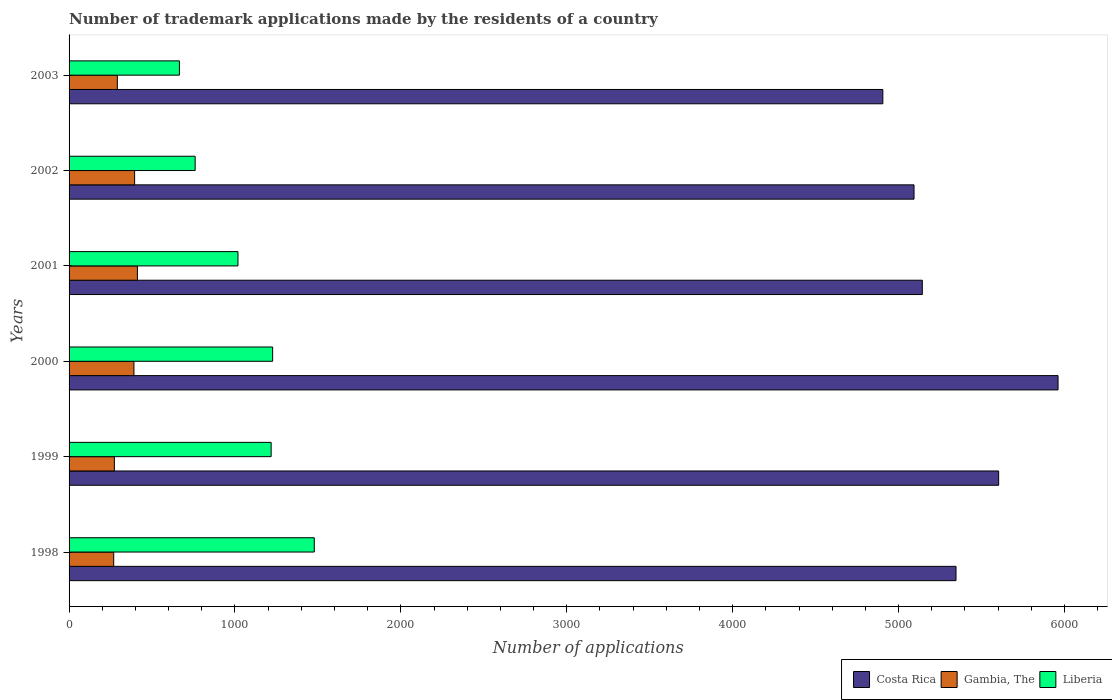How many groups of bars are there?
Give a very brief answer. 6. Are the number of bars per tick equal to the number of legend labels?
Your answer should be very brief. Yes. Are the number of bars on each tick of the Y-axis equal?
Provide a succinct answer. Yes. How many bars are there on the 4th tick from the bottom?
Provide a short and direct response. 3. In how many cases, is the number of bars for a given year not equal to the number of legend labels?
Your answer should be compact. 0. What is the number of trademark applications made by the residents in Costa Rica in 2003?
Make the answer very short. 4905. Across all years, what is the maximum number of trademark applications made by the residents in Gambia, The?
Offer a very short reply. 412. Across all years, what is the minimum number of trademark applications made by the residents in Gambia, The?
Provide a succinct answer. 269. In which year was the number of trademark applications made by the residents in Gambia, The maximum?
Make the answer very short. 2001. In which year was the number of trademark applications made by the residents in Costa Rica minimum?
Your answer should be very brief. 2003. What is the total number of trademark applications made by the residents in Liberia in the graph?
Give a very brief answer. 6366. What is the difference between the number of trademark applications made by the residents in Gambia, The in 1998 and that in 2000?
Offer a very short reply. -122. What is the difference between the number of trademark applications made by the residents in Costa Rica in 2003 and the number of trademark applications made by the residents in Gambia, The in 2002?
Offer a very short reply. 4510. What is the average number of trademark applications made by the residents in Costa Rica per year?
Your answer should be compact. 5341.83. In the year 2001, what is the difference between the number of trademark applications made by the residents in Gambia, The and number of trademark applications made by the residents in Costa Rica?
Give a very brief answer. -4731. What is the ratio of the number of trademark applications made by the residents in Gambia, The in 1998 to that in 2001?
Offer a very short reply. 0.65. Is the difference between the number of trademark applications made by the residents in Gambia, The in 1999 and 2001 greater than the difference between the number of trademark applications made by the residents in Costa Rica in 1999 and 2001?
Your answer should be compact. No. What is the difference between the highest and the lowest number of trademark applications made by the residents in Costa Rica?
Make the answer very short. 1056. What is the difference between two consecutive major ticks on the X-axis?
Make the answer very short. 1000. Are the values on the major ticks of X-axis written in scientific E-notation?
Give a very brief answer. No. Does the graph contain any zero values?
Give a very brief answer. No. Does the graph contain grids?
Your answer should be very brief. No. Where does the legend appear in the graph?
Your answer should be compact. Bottom right. How many legend labels are there?
Your answer should be compact. 3. How are the legend labels stacked?
Your response must be concise. Horizontal. What is the title of the graph?
Offer a very short reply. Number of trademark applications made by the residents of a country. Does "Cote d'Ivoire" appear as one of the legend labels in the graph?
Offer a terse response. No. What is the label or title of the X-axis?
Offer a very short reply. Number of applications. What is the label or title of the Y-axis?
Your answer should be compact. Years. What is the Number of applications of Costa Rica in 1998?
Your answer should be very brief. 5346. What is the Number of applications of Gambia, The in 1998?
Your response must be concise. 269. What is the Number of applications in Liberia in 1998?
Your response must be concise. 1478. What is the Number of applications in Costa Rica in 1999?
Provide a succinct answer. 5603. What is the Number of applications in Gambia, The in 1999?
Your answer should be very brief. 273. What is the Number of applications in Liberia in 1999?
Make the answer very short. 1218. What is the Number of applications of Costa Rica in 2000?
Provide a short and direct response. 5961. What is the Number of applications of Gambia, The in 2000?
Your answer should be very brief. 391. What is the Number of applications in Liberia in 2000?
Offer a terse response. 1227. What is the Number of applications in Costa Rica in 2001?
Provide a short and direct response. 5143. What is the Number of applications of Gambia, The in 2001?
Ensure brevity in your answer.  412. What is the Number of applications of Liberia in 2001?
Offer a very short reply. 1018. What is the Number of applications of Costa Rica in 2002?
Your answer should be compact. 5093. What is the Number of applications in Gambia, The in 2002?
Keep it short and to the point. 395. What is the Number of applications of Liberia in 2002?
Provide a short and direct response. 760. What is the Number of applications in Costa Rica in 2003?
Make the answer very short. 4905. What is the Number of applications of Gambia, The in 2003?
Ensure brevity in your answer.  291. What is the Number of applications in Liberia in 2003?
Provide a succinct answer. 665. Across all years, what is the maximum Number of applications of Costa Rica?
Your answer should be very brief. 5961. Across all years, what is the maximum Number of applications in Gambia, The?
Ensure brevity in your answer.  412. Across all years, what is the maximum Number of applications of Liberia?
Your answer should be very brief. 1478. Across all years, what is the minimum Number of applications of Costa Rica?
Provide a short and direct response. 4905. Across all years, what is the minimum Number of applications of Gambia, The?
Your answer should be compact. 269. Across all years, what is the minimum Number of applications in Liberia?
Provide a succinct answer. 665. What is the total Number of applications of Costa Rica in the graph?
Make the answer very short. 3.21e+04. What is the total Number of applications in Gambia, The in the graph?
Your answer should be very brief. 2031. What is the total Number of applications of Liberia in the graph?
Ensure brevity in your answer.  6366. What is the difference between the Number of applications of Costa Rica in 1998 and that in 1999?
Your answer should be compact. -257. What is the difference between the Number of applications in Gambia, The in 1998 and that in 1999?
Offer a terse response. -4. What is the difference between the Number of applications of Liberia in 1998 and that in 1999?
Keep it short and to the point. 260. What is the difference between the Number of applications of Costa Rica in 1998 and that in 2000?
Your answer should be very brief. -615. What is the difference between the Number of applications in Gambia, The in 1998 and that in 2000?
Provide a succinct answer. -122. What is the difference between the Number of applications in Liberia in 1998 and that in 2000?
Provide a short and direct response. 251. What is the difference between the Number of applications of Costa Rica in 1998 and that in 2001?
Make the answer very short. 203. What is the difference between the Number of applications in Gambia, The in 1998 and that in 2001?
Ensure brevity in your answer.  -143. What is the difference between the Number of applications in Liberia in 1998 and that in 2001?
Your answer should be very brief. 460. What is the difference between the Number of applications of Costa Rica in 1998 and that in 2002?
Provide a succinct answer. 253. What is the difference between the Number of applications of Gambia, The in 1998 and that in 2002?
Your response must be concise. -126. What is the difference between the Number of applications of Liberia in 1998 and that in 2002?
Offer a very short reply. 718. What is the difference between the Number of applications in Costa Rica in 1998 and that in 2003?
Provide a short and direct response. 441. What is the difference between the Number of applications of Liberia in 1998 and that in 2003?
Provide a short and direct response. 813. What is the difference between the Number of applications in Costa Rica in 1999 and that in 2000?
Your response must be concise. -358. What is the difference between the Number of applications in Gambia, The in 1999 and that in 2000?
Ensure brevity in your answer.  -118. What is the difference between the Number of applications of Liberia in 1999 and that in 2000?
Provide a succinct answer. -9. What is the difference between the Number of applications in Costa Rica in 1999 and that in 2001?
Give a very brief answer. 460. What is the difference between the Number of applications in Gambia, The in 1999 and that in 2001?
Ensure brevity in your answer.  -139. What is the difference between the Number of applications of Liberia in 1999 and that in 2001?
Ensure brevity in your answer.  200. What is the difference between the Number of applications in Costa Rica in 1999 and that in 2002?
Provide a short and direct response. 510. What is the difference between the Number of applications of Gambia, The in 1999 and that in 2002?
Provide a short and direct response. -122. What is the difference between the Number of applications in Liberia in 1999 and that in 2002?
Make the answer very short. 458. What is the difference between the Number of applications in Costa Rica in 1999 and that in 2003?
Your response must be concise. 698. What is the difference between the Number of applications in Gambia, The in 1999 and that in 2003?
Make the answer very short. -18. What is the difference between the Number of applications in Liberia in 1999 and that in 2003?
Ensure brevity in your answer.  553. What is the difference between the Number of applications of Costa Rica in 2000 and that in 2001?
Keep it short and to the point. 818. What is the difference between the Number of applications of Gambia, The in 2000 and that in 2001?
Your answer should be very brief. -21. What is the difference between the Number of applications in Liberia in 2000 and that in 2001?
Give a very brief answer. 209. What is the difference between the Number of applications of Costa Rica in 2000 and that in 2002?
Ensure brevity in your answer.  868. What is the difference between the Number of applications of Gambia, The in 2000 and that in 2002?
Offer a very short reply. -4. What is the difference between the Number of applications of Liberia in 2000 and that in 2002?
Make the answer very short. 467. What is the difference between the Number of applications of Costa Rica in 2000 and that in 2003?
Provide a short and direct response. 1056. What is the difference between the Number of applications of Liberia in 2000 and that in 2003?
Make the answer very short. 562. What is the difference between the Number of applications of Liberia in 2001 and that in 2002?
Make the answer very short. 258. What is the difference between the Number of applications in Costa Rica in 2001 and that in 2003?
Your answer should be very brief. 238. What is the difference between the Number of applications in Gambia, The in 2001 and that in 2003?
Keep it short and to the point. 121. What is the difference between the Number of applications of Liberia in 2001 and that in 2003?
Offer a terse response. 353. What is the difference between the Number of applications of Costa Rica in 2002 and that in 2003?
Offer a very short reply. 188. What is the difference between the Number of applications in Gambia, The in 2002 and that in 2003?
Give a very brief answer. 104. What is the difference between the Number of applications of Costa Rica in 1998 and the Number of applications of Gambia, The in 1999?
Offer a very short reply. 5073. What is the difference between the Number of applications in Costa Rica in 1998 and the Number of applications in Liberia in 1999?
Ensure brevity in your answer.  4128. What is the difference between the Number of applications in Gambia, The in 1998 and the Number of applications in Liberia in 1999?
Keep it short and to the point. -949. What is the difference between the Number of applications in Costa Rica in 1998 and the Number of applications in Gambia, The in 2000?
Your answer should be compact. 4955. What is the difference between the Number of applications in Costa Rica in 1998 and the Number of applications in Liberia in 2000?
Keep it short and to the point. 4119. What is the difference between the Number of applications of Gambia, The in 1998 and the Number of applications of Liberia in 2000?
Keep it short and to the point. -958. What is the difference between the Number of applications of Costa Rica in 1998 and the Number of applications of Gambia, The in 2001?
Provide a succinct answer. 4934. What is the difference between the Number of applications in Costa Rica in 1998 and the Number of applications in Liberia in 2001?
Provide a short and direct response. 4328. What is the difference between the Number of applications in Gambia, The in 1998 and the Number of applications in Liberia in 2001?
Keep it short and to the point. -749. What is the difference between the Number of applications of Costa Rica in 1998 and the Number of applications of Gambia, The in 2002?
Provide a succinct answer. 4951. What is the difference between the Number of applications in Costa Rica in 1998 and the Number of applications in Liberia in 2002?
Ensure brevity in your answer.  4586. What is the difference between the Number of applications of Gambia, The in 1998 and the Number of applications of Liberia in 2002?
Ensure brevity in your answer.  -491. What is the difference between the Number of applications of Costa Rica in 1998 and the Number of applications of Gambia, The in 2003?
Keep it short and to the point. 5055. What is the difference between the Number of applications of Costa Rica in 1998 and the Number of applications of Liberia in 2003?
Your answer should be compact. 4681. What is the difference between the Number of applications of Gambia, The in 1998 and the Number of applications of Liberia in 2003?
Your answer should be compact. -396. What is the difference between the Number of applications in Costa Rica in 1999 and the Number of applications in Gambia, The in 2000?
Keep it short and to the point. 5212. What is the difference between the Number of applications in Costa Rica in 1999 and the Number of applications in Liberia in 2000?
Your answer should be compact. 4376. What is the difference between the Number of applications of Gambia, The in 1999 and the Number of applications of Liberia in 2000?
Give a very brief answer. -954. What is the difference between the Number of applications in Costa Rica in 1999 and the Number of applications in Gambia, The in 2001?
Your response must be concise. 5191. What is the difference between the Number of applications of Costa Rica in 1999 and the Number of applications of Liberia in 2001?
Provide a short and direct response. 4585. What is the difference between the Number of applications in Gambia, The in 1999 and the Number of applications in Liberia in 2001?
Your answer should be compact. -745. What is the difference between the Number of applications of Costa Rica in 1999 and the Number of applications of Gambia, The in 2002?
Provide a succinct answer. 5208. What is the difference between the Number of applications in Costa Rica in 1999 and the Number of applications in Liberia in 2002?
Keep it short and to the point. 4843. What is the difference between the Number of applications in Gambia, The in 1999 and the Number of applications in Liberia in 2002?
Give a very brief answer. -487. What is the difference between the Number of applications in Costa Rica in 1999 and the Number of applications in Gambia, The in 2003?
Give a very brief answer. 5312. What is the difference between the Number of applications in Costa Rica in 1999 and the Number of applications in Liberia in 2003?
Your response must be concise. 4938. What is the difference between the Number of applications in Gambia, The in 1999 and the Number of applications in Liberia in 2003?
Your answer should be compact. -392. What is the difference between the Number of applications in Costa Rica in 2000 and the Number of applications in Gambia, The in 2001?
Offer a very short reply. 5549. What is the difference between the Number of applications of Costa Rica in 2000 and the Number of applications of Liberia in 2001?
Ensure brevity in your answer.  4943. What is the difference between the Number of applications in Gambia, The in 2000 and the Number of applications in Liberia in 2001?
Give a very brief answer. -627. What is the difference between the Number of applications in Costa Rica in 2000 and the Number of applications in Gambia, The in 2002?
Provide a short and direct response. 5566. What is the difference between the Number of applications of Costa Rica in 2000 and the Number of applications of Liberia in 2002?
Ensure brevity in your answer.  5201. What is the difference between the Number of applications of Gambia, The in 2000 and the Number of applications of Liberia in 2002?
Offer a terse response. -369. What is the difference between the Number of applications of Costa Rica in 2000 and the Number of applications of Gambia, The in 2003?
Provide a short and direct response. 5670. What is the difference between the Number of applications of Costa Rica in 2000 and the Number of applications of Liberia in 2003?
Provide a short and direct response. 5296. What is the difference between the Number of applications in Gambia, The in 2000 and the Number of applications in Liberia in 2003?
Provide a succinct answer. -274. What is the difference between the Number of applications in Costa Rica in 2001 and the Number of applications in Gambia, The in 2002?
Offer a terse response. 4748. What is the difference between the Number of applications of Costa Rica in 2001 and the Number of applications of Liberia in 2002?
Your response must be concise. 4383. What is the difference between the Number of applications in Gambia, The in 2001 and the Number of applications in Liberia in 2002?
Provide a short and direct response. -348. What is the difference between the Number of applications in Costa Rica in 2001 and the Number of applications in Gambia, The in 2003?
Keep it short and to the point. 4852. What is the difference between the Number of applications in Costa Rica in 2001 and the Number of applications in Liberia in 2003?
Your answer should be compact. 4478. What is the difference between the Number of applications of Gambia, The in 2001 and the Number of applications of Liberia in 2003?
Your answer should be compact. -253. What is the difference between the Number of applications of Costa Rica in 2002 and the Number of applications of Gambia, The in 2003?
Your answer should be compact. 4802. What is the difference between the Number of applications of Costa Rica in 2002 and the Number of applications of Liberia in 2003?
Ensure brevity in your answer.  4428. What is the difference between the Number of applications of Gambia, The in 2002 and the Number of applications of Liberia in 2003?
Offer a terse response. -270. What is the average Number of applications of Costa Rica per year?
Ensure brevity in your answer.  5341.83. What is the average Number of applications of Gambia, The per year?
Your answer should be very brief. 338.5. What is the average Number of applications of Liberia per year?
Your answer should be very brief. 1061. In the year 1998, what is the difference between the Number of applications of Costa Rica and Number of applications of Gambia, The?
Provide a short and direct response. 5077. In the year 1998, what is the difference between the Number of applications of Costa Rica and Number of applications of Liberia?
Offer a terse response. 3868. In the year 1998, what is the difference between the Number of applications of Gambia, The and Number of applications of Liberia?
Offer a terse response. -1209. In the year 1999, what is the difference between the Number of applications of Costa Rica and Number of applications of Gambia, The?
Your answer should be very brief. 5330. In the year 1999, what is the difference between the Number of applications of Costa Rica and Number of applications of Liberia?
Make the answer very short. 4385. In the year 1999, what is the difference between the Number of applications of Gambia, The and Number of applications of Liberia?
Your answer should be very brief. -945. In the year 2000, what is the difference between the Number of applications of Costa Rica and Number of applications of Gambia, The?
Offer a very short reply. 5570. In the year 2000, what is the difference between the Number of applications of Costa Rica and Number of applications of Liberia?
Offer a very short reply. 4734. In the year 2000, what is the difference between the Number of applications in Gambia, The and Number of applications in Liberia?
Your response must be concise. -836. In the year 2001, what is the difference between the Number of applications of Costa Rica and Number of applications of Gambia, The?
Give a very brief answer. 4731. In the year 2001, what is the difference between the Number of applications in Costa Rica and Number of applications in Liberia?
Provide a succinct answer. 4125. In the year 2001, what is the difference between the Number of applications of Gambia, The and Number of applications of Liberia?
Your answer should be compact. -606. In the year 2002, what is the difference between the Number of applications of Costa Rica and Number of applications of Gambia, The?
Give a very brief answer. 4698. In the year 2002, what is the difference between the Number of applications of Costa Rica and Number of applications of Liberia?
Provide a short and direct response. 4333. In the year 2002, what is the difference between the Number of applications in Gambia, The and Number of applications in Liberia?
Give a very brief answer. -365. In the year 2003, what is the difference between the Number of applications of Costa Rica and Number of applications of Gambia, The?
Make the answer very short. 4614. In the year 2003, what is the difference between the Number of applications in Costa Rica and Number of applications in Liberia?
Provide a short and direct response. 4240. In the year 2003, what is the difference between the Number of applications of Gambia, The and Number of applications of Liberia?
Ensure brevity in your answer.  -374. What is the ratio of the Number of applications in Costa Rica in 1998 to that in 1999?
Your response must be concise. 0.95. What is the ratio of the Number of applications in Gambia, The in 1998 to that in 1999?
Your answer should be very brief. 0.99. What is the ratio of the Number of applications of Liberia in 1998 to that in 1999?
Your answer should be compact. 1.21. What is the ratio of the Number of applications of Costa Rica in 1998 to that in 2000?
Give a very brief answer. 0.9. What is the ratio of the Number of applications of Gambia, The in 1998 to that in 2000?
Provide a succinct answer. 0.69. What is the ratio of the Number of applications of Liberia in 1998 to that in 2000?
Ensure brevity in your answer.  1.2. What is the ratio of the Number of applications in Costa Rica in 1998 to that in 2001?
Keep it short and to the point. 1.04. What is the ratio of the Number of applications of Gambia, The in 1998 to that in 2001?
Ensure brevity in your answer.  0.65. What is the ratio of the Number of applications of Liberia in 1998 to that in 2001?
Ensure brevity in your answer.  1.45. What is the ratio of the Number of applications of Costa Rica in 1998 to that in 2002?
Keep it short and to the point. 1.05. What is the ratio of the Number of applications in Gambia, The in 1998 to that in 2002?
Your answer should be compact. 0.68. What is the ratio of the Number of applications of Liberia in 1998 to that in 2002?
Your response must be concise. 1.94. What is the ratio of the Number of applications of Costa Rica in 1998 to that in 2003?
Make the answer very short. 1.09. What is the ratio of the Number of applications of Gambia, The in 1998 to that in 2003?
Your answer should be very brief. 0.92. What is the ratio of the Number of applications in Liberia in 1998 to that in 2003?
Your answer should be compact. 2.22. What is the ratio of the Number of applications of Costa Rica in 1999 to that in 2000?
Your response must be concise. 0.94. What is the ratio of the Number of applications in Gambia, The in 1999 to that in 2000?
Provide a short and direct response. 0.7. What is the ratio of the Number of applications of Costa Rica in 1999 to that in 2001?
Your answer should be very brief. 1.09. What is the ratio of the Number of applications in Gambia, The in 1999 to that in 2001?
Make the answer very short. 0.66. What is the ratio of the Number of applications in Liberia in 1999 to that in 2001?
Provide a succinct answer. 1.2. What is the ratio of the Number of applications in Costa Rica in 1999 to that in 2002?
Offer a very short reply. 1.1. What is the ratio of the Number of applications in Gambia, The in 1999 to that in 2002?
Your answer should be compact. 0.69. What is the ratio of the Number of applications of Liberia in 1999 to that in 2002?
Your answer should be compact. 1.6. What is the ratio of the Number of applications of Costa Rica in 1999 to that in 2003?
Give a very brief answer. 1.14. What is the ratio of the Number of applications in Gambia, The in 1999 to that in 2003?
Give a very brief answer. 0.94. What is the ratio of the Number of applications of Liberia in 1999 to that in 2003?
Keep it short and to the point. 1.83. What is the ratio of the Number of applications of Costa Rica in 2000 to that in 2001?
Ensure brevity in your answer.  1.16. What is the ratio of the Number of applications of Gambia, The in 2000 to that in 2001?
Offer a terse response. 0.95. What is the ratio of the Number of applications in Liberia in 2000 to that in 2001?
Your answer should be very brief. 1.21. What is the ratio of the Number of applications in Costa Rica in 2000 to that in 2002?
Keep it short and to the point. 1.17. What is the ratio of the Number of applications of Liberia in 2000 to that in 2002?
Give a very brief answer. 1.61. What is the ratio of the Number of applications of Costa Rica in 2000 to that in 2003?
Provide a short and direct response. 1.22. What is the ratio of the Number of applications in Gambia, The in 2000 to that in 2003?
Provide a short and direct response. 1.34. What is the ratio of the Number of applications of Liberia in 2000 to that in 2003?
Offer a terse response. 1.85. What is the ratio of the Number of applications in Costa Rica in 2001 to that in 2002?
Keep it short and to the point. 1.01. What is the ratio of the Number of applications of Gambia, The in 2001 to that in 2002?
Make the answer very short. 1.04. What is the ratio of the Number of applications of Liberia in 2001 to that in 2002?
Your response must be concise. 1.34. What is the ratio of the Number of applications in Costa Rica in 2001 to that in 2003?
Give a very brief answer. 1.05. What is the ratio of the Number of applications of Gambia, The in 2001 to that in 2003?
Your response must be concise. 1.42. What is the ratio of the Number of applications of Liberia in 2001 to that in 2003?
Offer a very short reply. 1.53. What is the ratio of the Number of applications in Costa Rica in 2002 to that in 2003?
Your response must be concise. 1.04. What is the ratio of the Number of applications in Gambia, The in 2002 to that in 2003?
Offer a very short reply. 1.36. What is the ratio of the Number of applications in Liberia in 2002 to that in 2003?
Keep it short and to the point. 1.14. What is the difference between the highest and the second highest Number of applications in Costa Rica?
Your answer should be very brief. 358. What is the difference between the highest and the second highest Number of applications of Gambia, The?
Give a very brief answer. 17. What is the difference between the highest and the second highest Number of applications in Liberia?
Provide a succinct answer. 251. What is the difference between the highest and the lowest Number of applications in Costa Rica?
Your answer should be very brief. 1056. What is the difference between the highest and the lowest Number of applications in Gambia, The?
Provide a short and direct response. 143. What is the difference between the highest and the lowest Number of applications in Liberia?
Your answer should be compact. 813. 